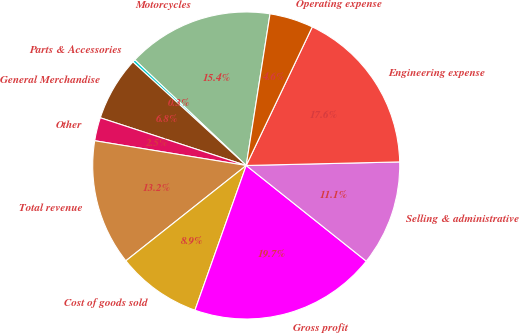<chart> <loc_0><loc_0><loc_500><loc_500><pie_chart><fcel>Motorcycles<fcel>Parts & Accessories<fcel>General Merchandise<fcel>Other<fcel>Total revenue<fcel>Cost of goods sold<fcel>Gross profit<fcel>Selling & administrative<fcel>Engineering expense<fcel>Operating expense<nl><fcel>15.4%<fcel>0.29%<fcel>6.76%<fcel>2.45%<fcel>13.24%<fcel>8.92%<fcel>19.71%<fcel>11.08%<fcel>17.55%<fcel>4.6%<nl></chart> 